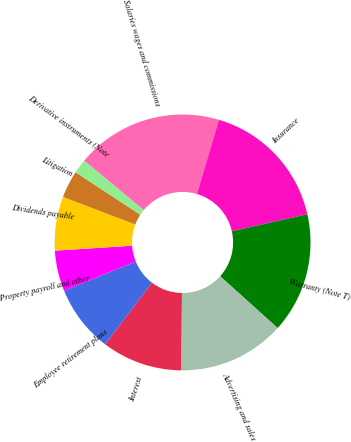Convert chart to OTSL. <chart><loc_0><loc_0><loc_500><loc_500><pie_chart><fcel>Salaries wages and commissions<fcel>Insurance<fcel>Warranty (Note T)<fcel>Advertising and sales<fcel>Interest<fcel>Employee retirement plans<fcel>Property payroll and other<fcel>Dividends payable<fcel>Litigation<fcel>Derivative instruments (Note<nl><fcel>18.56%<fcel>16.88%<fcel>15.2%<fcel>13.52%<fcel>10.17%<fcel>8.49%<fcel>5.13%<fcel>6.81%<fcel>3.46%<fcel>1.78%<nl></chart> 